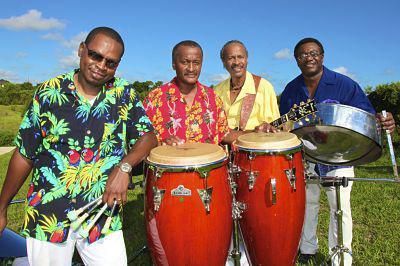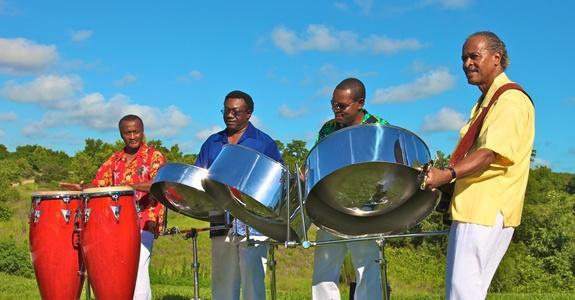The first image is the image on the left, the second image is the image on the right. Assess this claim about the two images: "Some musicians are wearing hats.". Correct or not? Answer yes or no. No. The first image is the image on the left, the second image is the image on the right. Considering the images on both sides, is "Each image includes at least three men standing behind drums, and at least one man in each image is wearing a hawaiian shirt." valid? Answer yes or no. Yes. 